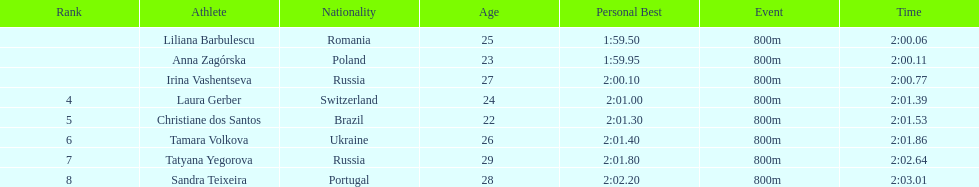What was the time difference between the first place finisher and the eighth place finisher? 2.95. 